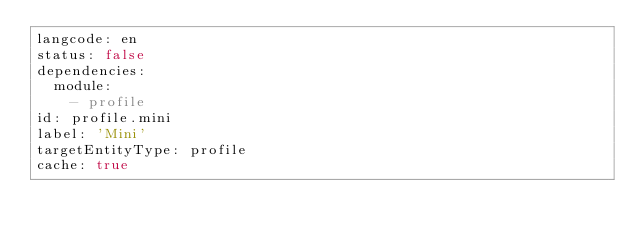<code> <loc_0><loc_0><loc_500><loc_500><_YAML_>langcode: en
status: false
dependencies:
  module:
    - profile
id: profile.mini
label: 'Mini'
targetEntityType: profile
cache: true
</code> 